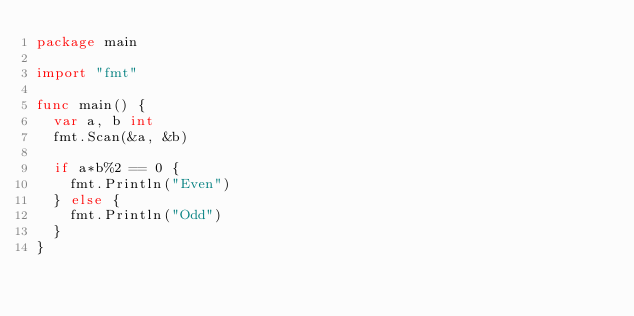<code> <loc_0><loc_0><loc_500><loc_500><_Go_>package main

import "fmt"

func main() {
	var a, b int
	fmt.Scan(&a, &b)

	if a*b%2 == 0 {
		fmt.Println("Even")
	} else {
		fmt.Println("Odd")
	}
}
</code> 